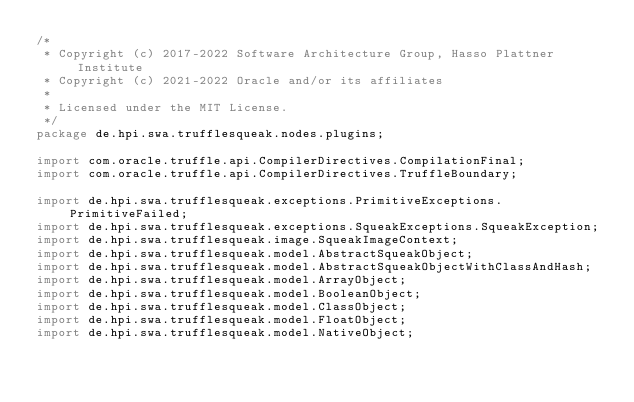<code> <loc_0><loc_0><loc_500><loc_500><_Java_>/*
 * Copyright (c) 2017-2022 Software Architecture Group, Hasso Plattner Institute
 * Copyright (c) 2021-2022 Oracle and/or its affiliates
 *
 * Licensed under the MIT License.
 */
package de.hpi.swa.trufflesqueak.nodes.plugins;

import com.oracle.truffle.api.CompilerDirectives.CompilationFinal;
import com.oracle.truffle.api.CompilerDirectives.TruffleBoundary;

import de.hpi.swa.trufflesqueak.exceptions.PrimitiveExceptions.PrimitiveFailed;
import de.hpi.swa.trufflesqueak.exceptions.SqueakExceptions.SqueakException;
import de.hpi.swa.trufflesqueak.image.SqueakImageContext;
import de.hpi.swa.trufflesqueak.model.AbstractSqueakObject;
import de.hpi.swa.trufflesqueak.model.AbstractSqueakObjectWithClassAndHash;
import de.hpi.swa.trufflesqueak.model.ArrayObject;
import de.hpi.swa.trufflesqueak.model.BooleanObject;
import de.hpi.swa.trufflesqueak.model.ClassObject;
import de.hpi.swa.trufflesqueak.model.FloatObject;
import de.hpi.swa.trufflesqueak.model.NativeObject;</code> 